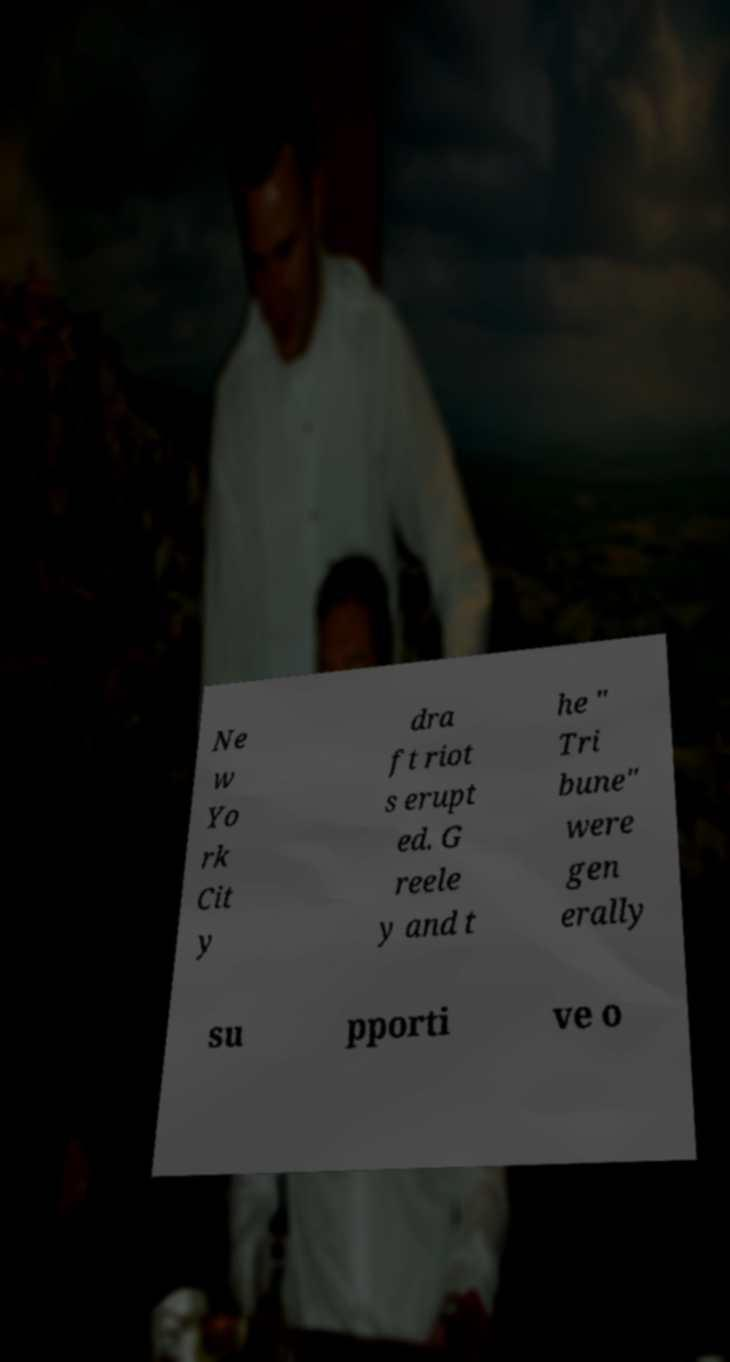Could you extract and type out the text from this image? Ne w Yo rk Cit y dra ft riot s erupt ed. G reele y and t he " Tri bune" were gen erally su pporti ve o 